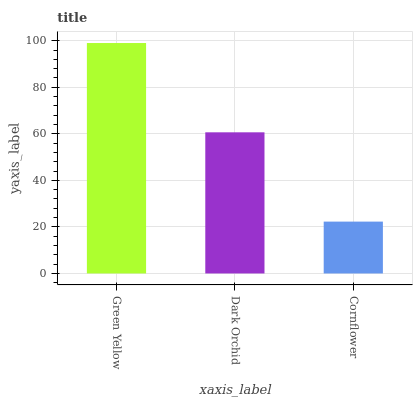Is Dark Orchid the minimum?
Answer yes or no. No. Is Dark Orchid the maximum?
Answer yes or no. No. Is Green Yellow greater than Dark Orchid?
Answer yes or no. Yes. Is Dark Orchid less than Green Yellow?
Answer yes or no. Yes. Is Dark Orchid greater than Green Yellow?
Answer yes or no. No. Is Green Yellow less than Dark Orchid?
Answer yes or no. No. Is Dark Orchid the high median?
Answer yes or no. Yes. Is Dark Orchid the low median?
Answer yes or no. Yes. Is Green Yellow the high median?
Answer yes or no. No. Is Cornflower the low median?
Answer yes or no. No. 